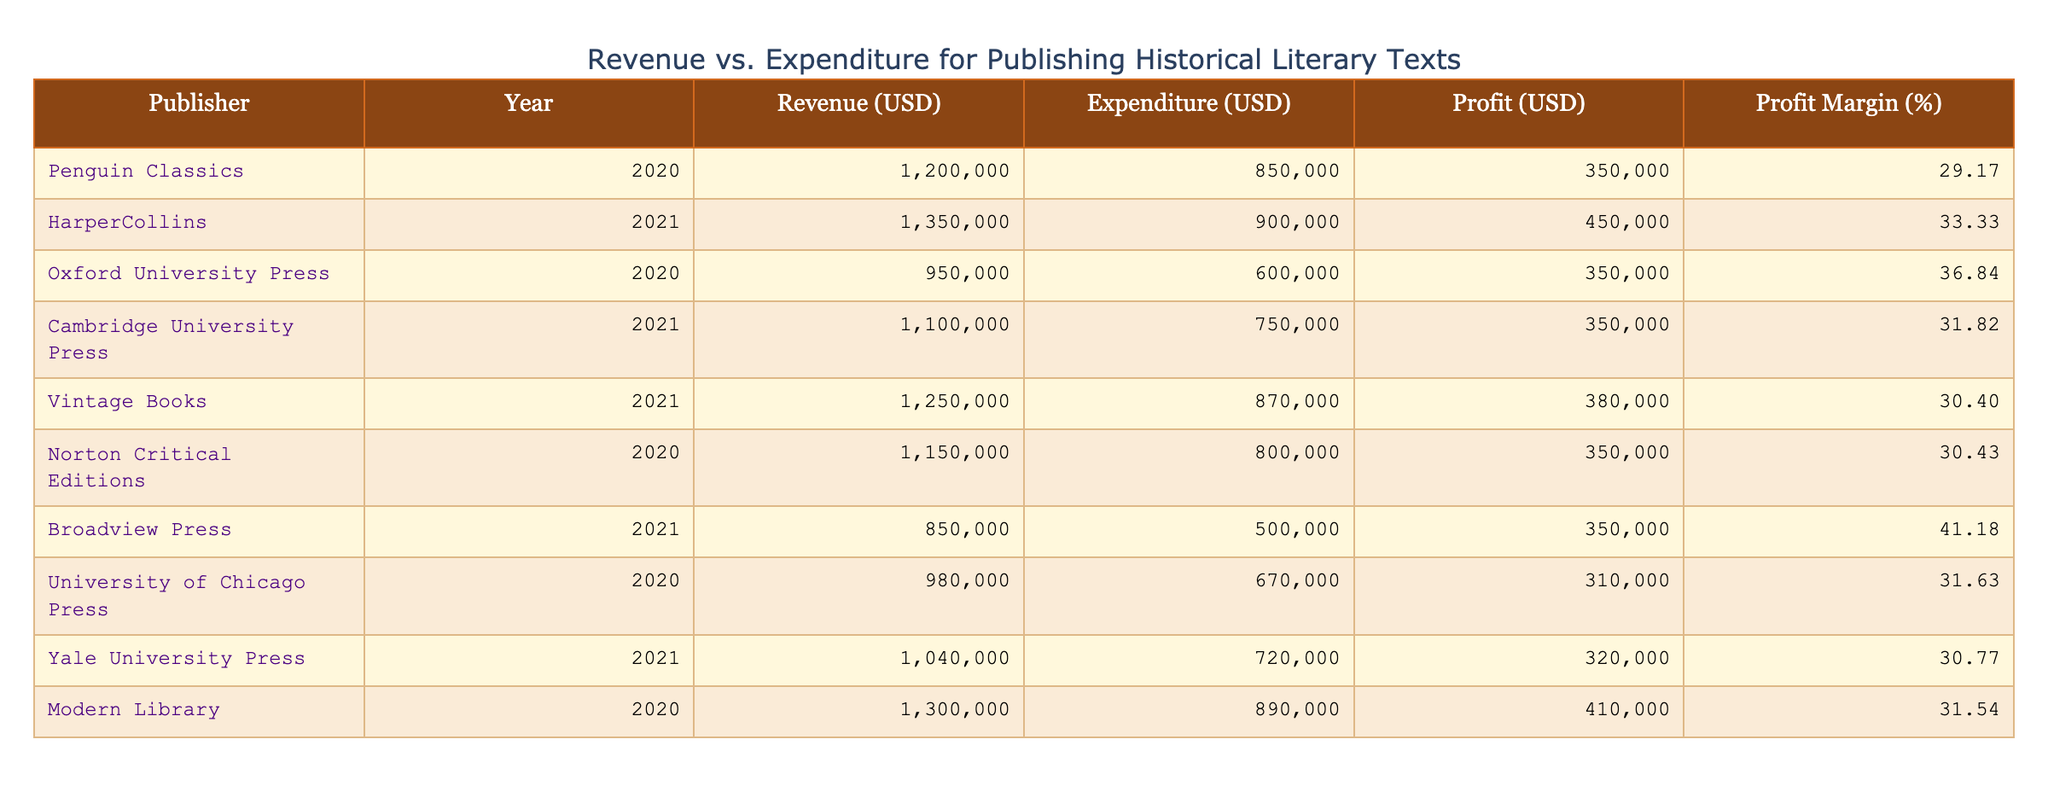What is the revenue of Penguin Classics in 2020? The revenue for Penguin Classics in 2020 is explicitly listed in the table. It shows that the revenue is 1,200,000 USD.
Answer: 1,200,000 USD Which publisher had the highest expenditure in 2021? The table indicates the expenditure for each publisher in 2021. By comparing the values, Vintage Books has the highest expenditure of 870,000 USD.
Answer: Vintage Books What is the profit margin for Oxford University Press in 2020? To find the profit margin, we first calculate the profit by subtracting expenditure from revenue: 950,000 - 600,000 = 350,000 USD. Then, the profit margin is calculated as (350,000 / 950,000) * 100, which equals approximately 36.84%.
Answer: 36.84% Did HarperCollins have a profit in 2021? HarperCollins' revenue and expenditure for 2021 are listed as 1,350,000 USD and 900,000 USD respectively. Since revenue is greater than expenditure, HarperCollins indeed made a profit.
Answer: Yes What is the average revenue of all publishers listed for 2020? To find the average revenue for 2020, we first sum the revenues: 1,200,000 (Penguin Classics) + 950,000 (Oxford University Press) + 1,150,000 (Norton Critical Editions) + 980,000 (University of Chicago Press) + 1,300,000 (Modern Library) = 5,580,000 USD. Dividing by the number of publishers (5), the average revenue is 5,580,000 / 5 = 1,116,000 USD.
Answer: 1,116,000 USD Which publisher showed the biggest profit in 2021? First, we calculate the profit for each publisher in 2021 by subtracting expenditure from revenue. The profits are as follows: HarperCollins (450,000 USD), Cambridge University Press (350,000 USD), Vintage Books (380,000 USD), and Yale University Press (320,000 USD). The highest profit among these is by HarperCollins, with a profit of 450,000 USD.
Answer: HarperCollins 